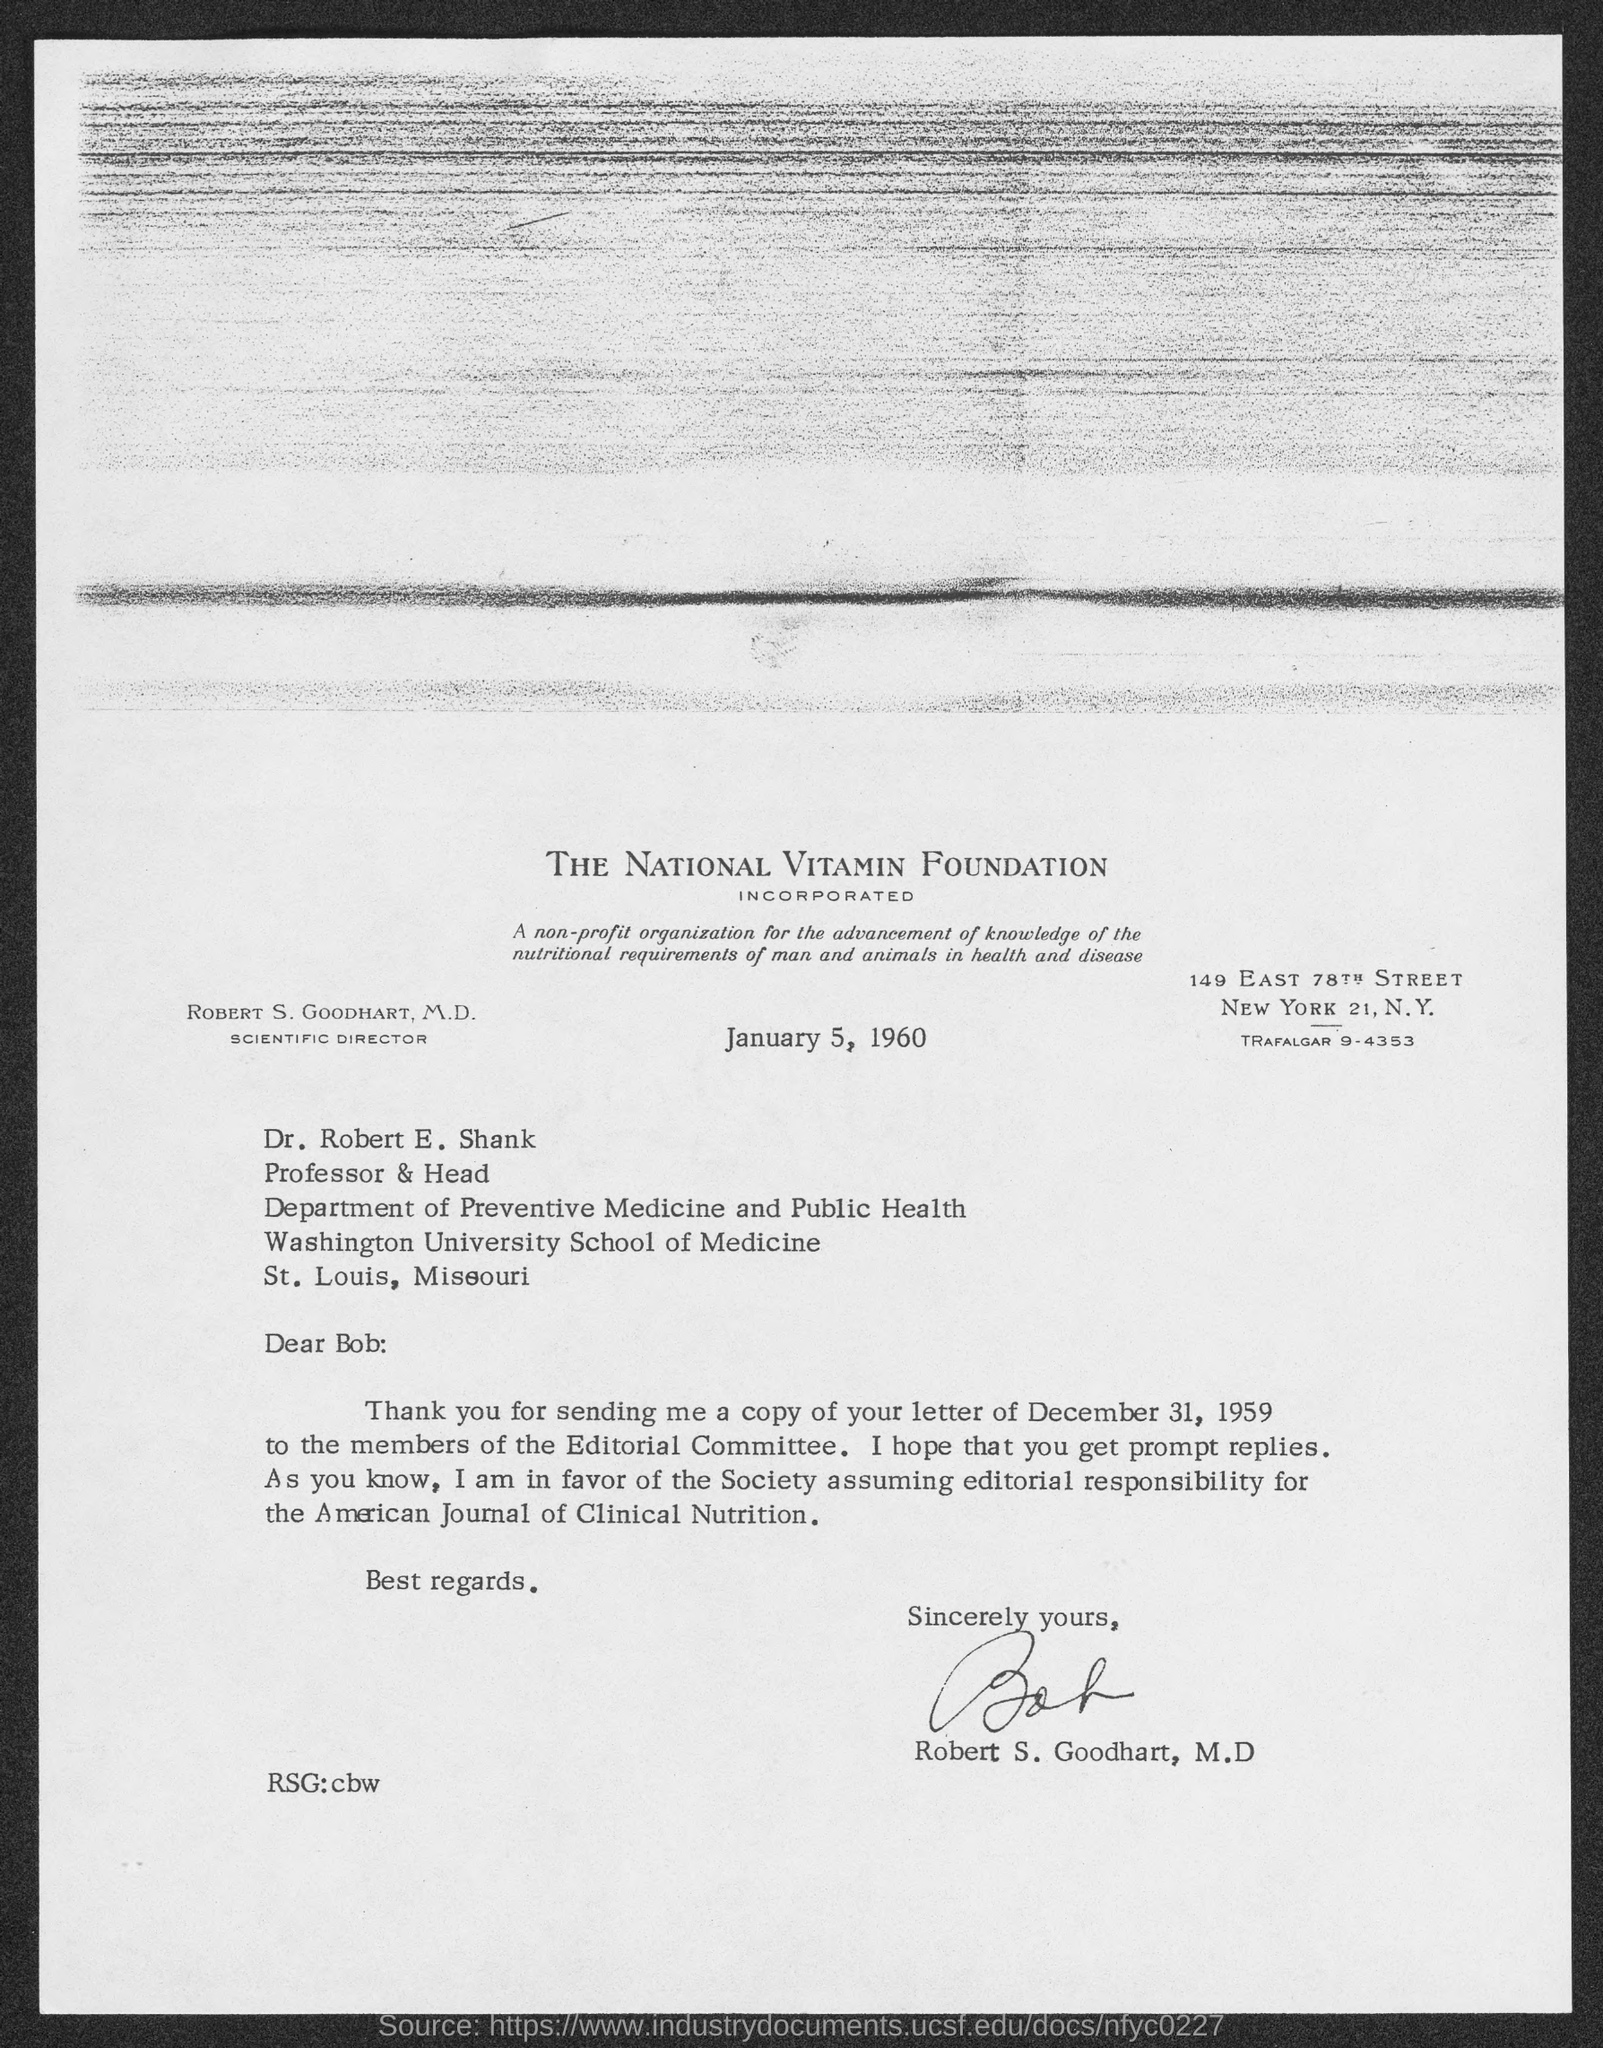What is the date on the document?
Give a very brief answer. January 5, 1960. Who is this letter from?
Make the answer very short. Robert S. Goodhart, M.D. 